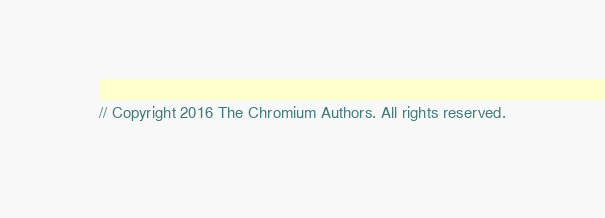<code> <loc_0><loc_0><loc_500><loc_500><_ObjectiveC_>// Copyright 2016 The Chromium Authors. All rights reserved.</code> 